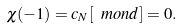Convert formula to latex. <formula><loc_0><loc_0><loc_500><loc_500>\chi ( - 1 ) = c _ { N } [ \ m o n d ] = 0 .</formula> 